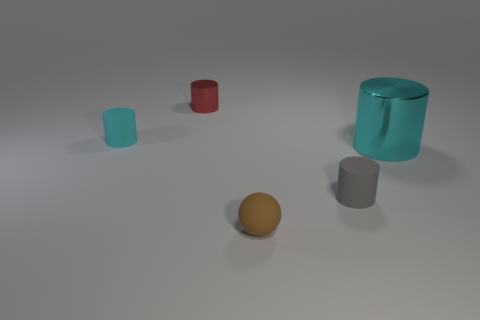Subtract all red metallic cylinders. How many cylinders are left? 3 Add 1 gray cylinders. How many objects exist? 6 Subtract all cyan cylinders. How many cylinders are left? 2 Subtract 1 cylinders. How many cylinders are left? 3 Subtract all cylinders. How many objects are left? 1 Subtract all brown spheres. Subtract all tiny matte things. How many objects are left? 1 Add 3 brown rubber balls. How many brown rubber balls are left? 4 Add 2 things. How many things exist? 7 Subtract 0 green blocks. How many objects are left? 5 Subtract all red balls. Subtract all green blocks. How many balls are left? 1 